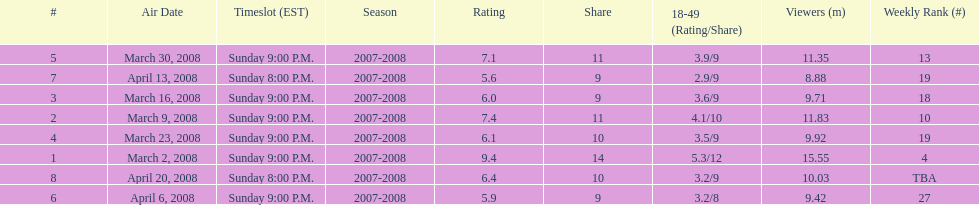What time slot did the show have for its first 6 episodes? Sunday 9:00 P.M. 